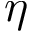<formula> <loc_0><loc_0><loc_500><loc_500>\eta</formula> 